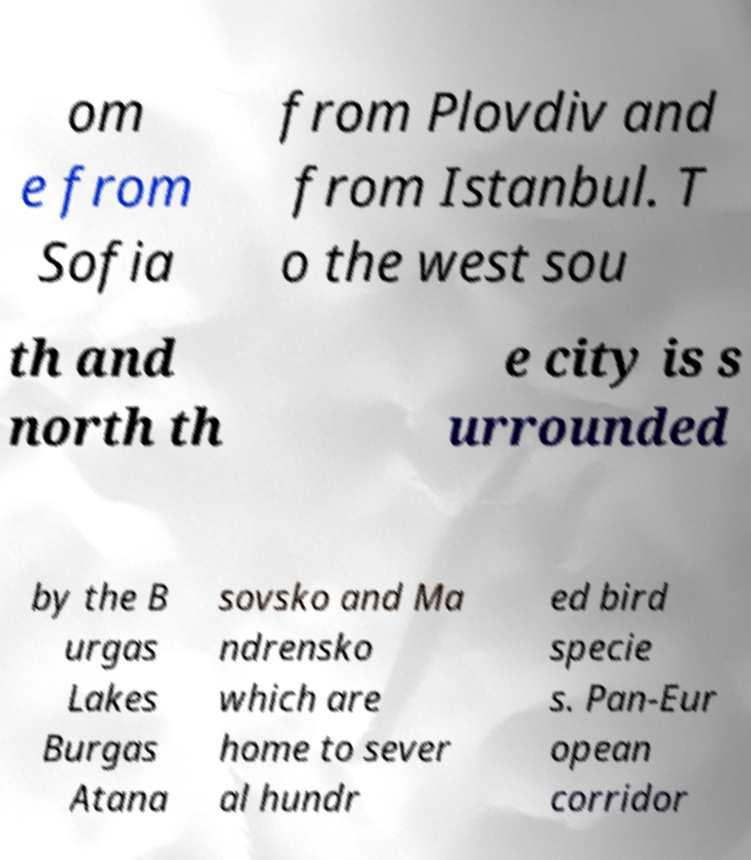Could you extract and type out the text from this image? om e from Sofia from Plovdiv and from Istanbul. T o the west sou th and north th e city is s urrounded by the B urgas Lakes Burgas Atana sovsko and Ma ndrensko which are home to sever al hundr ed bird specie s. Pan-Eur opean corridor 